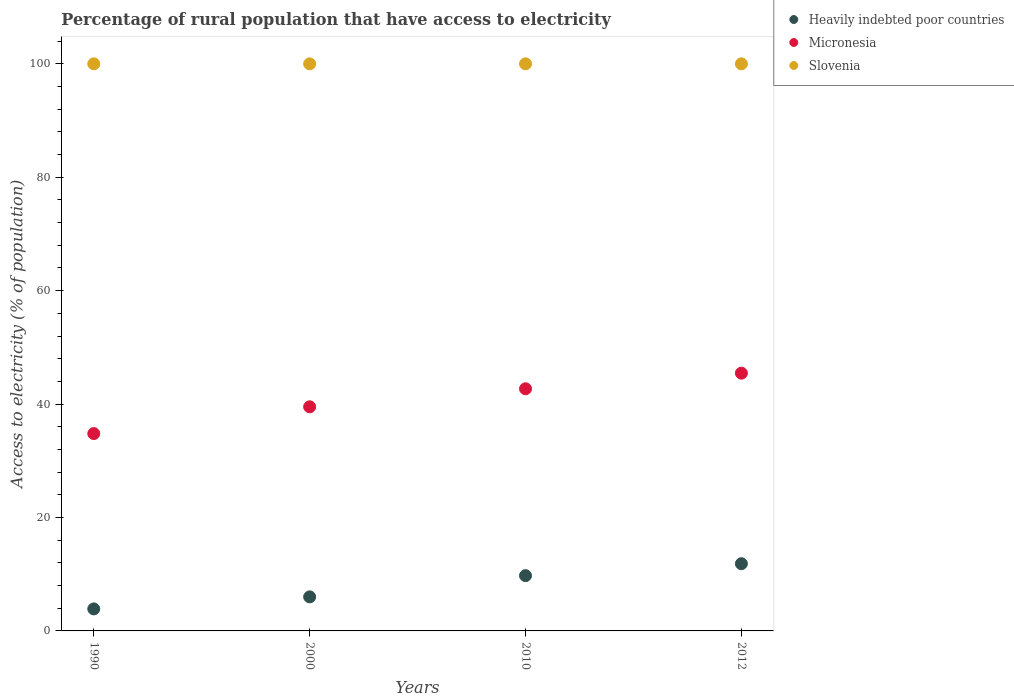How many different coloured dotlines are there?
Provide a short and direct response. 3. Is the number of dotlines equal to the number of legend labels?
Offer a very short reply. Yes. What is the percentage of rural population that have access to electricity in Heavily indebted poor countries in 2012?
Make the answer very short. 11.85. Across all years, what is the maximum percentage of rural population that have access to electricity in Heavily indebted poor countries?
Give a very brief answer. 11.85. Across all years, what is the minimum percentage of rural population that have access to electricity in Micronesia?
Make the answer very short. 34.8. In which year was the percentage of rural population that have access to electricity in Slovenia maximum?
Offer a very short reply. 1990. In which year was the percentage of rural population that have access to electricity in Slovenia minimum?
Offer a very short reply. 1990. What is the total percentage of rural population that have access to electricity in Heavily indebted poor countries in the graph?
Offer a terse response. 31.49. What is the difference between the percentage of rural population that have access to electricity in Slovenia in 1990 and that in 2000?
Give a very brief answer. 0. What is the difference between the percentage of rural population that have access to electricity in Slovenia in 1990 and the percentage of rural population that have access to electricity in Heavily indebted poor countries in 2010?
Provide a succinct answer. 90.25. In the year 2012, what is the difference between the percentage of rural population that have access to electricity in Heavily indebted poor countries and percentage of rural population that have access to electricity in Slovenia?
Ensure brevity in your answer.  -88.15. What is the ratio of the percentage of rural population that have access to electricity in Slovenia in 1990 to that in 2010?
Give a very brief answer. 1. What is the difference between the highest and the second highest percentage of rural population that have access to electricity in Heavily indebted poor countries?
Offer a very short reply. 2.11. What is the difference between the highest and the lowest percentage of rural population that have access to electricity in Heavily indebted poor countries?
Provide a succinct answer. 7.97. Is the sum of the percentage of rural population that have access to electricity in Heavily indebted poor countries in 1990 and 2000 greater than the maximum percentage of rural population that have access to electricity in Micronesia across all years?
Your response must be concise. No. Does the percentage of rural population that have access to electricity in Heavily indebted poor countries monotonically increase over the years?
Give a very brief answer. Yes. Is the percentage of rural population that have access to electricity in Heavily indebted poor countries strictly less than the percentage of rural population that have access to electricity in Slovenia over the years?
Offer a very short reply. Yes. How many dotlines are there?
Offer a terse response. 3. How many years are there in the graph?
Keep it short and to the point. 4. Where does the legend appear in the graph?
Offer a terse response. Top right. How many legend labels are there?
Give a very brief answer. 3. How are the legend labels stacked?
Offer a terse response. Vertical. What is the title of the graph?
Offer a terse response. Percentage of rural population that have access to electricity. What is the label or title of the X-axis?
Your response must be concise. Years. What is the label or title of the Y-axis?
Make the answer very short. Access to electricity (% of population). What is the Access to electricity (% of population) of Heavily indebted poor countries in 1990?
Provide a short and direct response. 3.88. What is the Access to electricity (% of population) of Micronesia in 1990?
Offer a terse response. 34.8. What is the Access to electricity (% of population) in Slovenia in 1990?
Ensure brevity in your answer.  100. What is the Access to electricity (% of population) of Heavily indebted poor countries in 2000?
Your answer should be very brief. 6. What is the Access to electricity (% of population) in Micronesia in 2000?
Make the answer very short. 39.52. What is the Access to electricity (% of population) of Slovenia in 2000?
Keep it short and to the point. 100. What is the Access to electricity (% of population) of Heavily indebted poor countries in 2010?
Give a very brief answer. 9.75. What is the Access to electricity (% of population) in Micronesia in 2010?
Give a very brief answer. 42.7. What is the Access to electricity (% of population) in Slovenia in 2010?
Your answer should be very brief. 100. What is the Access to electricity (% of population) in Heavily indebted poor countries in 2012?
Keep it short and to the point. 11.85. What is the Access to electricity (% of population) in Micronesia in 2012?
Your response must be concise. 45.45. Across all years, what is the maximum Access to electricity (% of population) of Heavily indebted poor countries?
Offer a terse response. 11.85. Across all years, what is the maximum Access to electricity (% of population) in Micronesia?
Your response must be concise. 45.45. Across all years, what is the minimum Access to electricity (% of population) of Heavily indebted poor countries?
Your answer should be very brief. 3.88. Across all years, what is the minimum Access to electricity (% of population) in Micronesia?
Make the answer very short. 34.8. What is the total Access to electricity (% of population) of Heavily indebted poor countries in the graph?
Provide a succinct answer. 31.49. What is the total Access to electricity (% of population) of Micronesia in the graph?
Your answer should be very brief. 162.47. What is the total Access to electricity (% of population) in Slovenia in the graph?
Ensure brevity in your answer.  400. What is the difference between the Access to electricity (% of population) of Heavily indebted poor countries in 1990 and that in 2000?
Your answer should be very brief. -2.12. What is the difference between the Access to electricity (% of population) in Micronesia in 1990 and that in 2000?
Make the answer very short. -4.72. What is the difference between the Access to electricity (% of population) in Heavily indebted poor countries in 1990 and that in 2010?
Provide a succinct answer. -5.86. What is the difference between the Access to electricity (% of population) in Micronesia in 1990 and that in 2010?
Make the answer very short. -7.9. What is the difference between the Access to electricity (% of population) of Heavily indebted poor countries in 1990 and that in 2012?
Your answer should be very brief. -7.97. What is the difference between the Access to electricity (% of population) in Micronesia in 1990 and that in 2012?
Your answer should be compact. -10.66. What is the difference between the Access to electricity (% of population) of Slovenia in 1990 and that in 2012?
Provide a succinct answer. 0. What is the difference between the Access to electricity (% of population) of Heavily indebted poor countries in 2000 and that in 2010?
Ensure brevity in your answer.  -3.74. What is the difference between the Access to electricity (% of population) of Micronesia in 2000 and that in 2010?
Your answer should be compact. -3.18. What is the difference between the Access to electricity (% of population) of Heavily indebted poor countries in 2000 and that in 2012?
Provide a short and direct response. -5.85. What is the difference between the Access to electricity (% of population) of Micronesia in 2000 and that in 2012?
Make the answer very short. -5.93. What is the difference between the Access to electricity (% of population) in Heavily indebted poor countries in 2010 and that in 2012?
Offer a very short reply. -2.11. What is the difference between the Access to electricity (% of population) of Micronesia in 2010 and that in 2012?
Make the answer very short. -2.75. What is the difference between the Access to electricity (% of population) in Heavily indebted poor countries in 1990 and the Access to electricity (% of population) in Micronesia in 2000?
Provide a short and direct response. -35.64. What is the difference between the Access to electricity (% of population) in Heavily indebted poor countries in 1990 and the Access to electricity (% of population) in Slovenia in 2000?
Ensure brevity in your answer.  -96.12. What is the difference between the Access to electricity (% of population) of Micronesia in 1990 and the Access to electricity (% of population) of Slovenia in 2000?
Make the answer very short. -65.2. What is the difference between the Access to electricity (% of population) of Heavily indebted poor countries in 1990 and the Access to electricity (% of population) of Micronesia in 2010?
Your answer should be very brief. -38.82. What is the difference between the Access to electricity (% of population) of Heavily indebted poor countries in 1990 and the Access to electricity (% of population) of Slovenia in 2010?
Your answer should be compact. -96.12. What is the difference between the Access to electricity (% of population) in Micronesia in 1990 and the Access to electricity (% of population) in Slovenia in 2010?
Your response must be concise. -65.2. What is the difference between the Access to electricity (% of population) in Heavily indebted poor countries in 1990 and the Access to electricity (% of population) in Micronesia in 2012?
Your answer should be compact. -41.57. What is the difference between the Access to electricity (% of population) in Heavily indebted poor countries in 1990 and the Access to electricity (% of population) in Slovenia in 2012?
Offer a terse response. -96.12. What is the difference between the Access to electricity (% of population) of Micronesia in 1990 and the Access to electricity (% of population) of Slovenia in 2012?
Your answer should be very brief. -65.2. What is the difference between the Access to electricity (% of population) of Heavily indebted poor countries in 2000 and the Access to electricity (% of population) of Micronesia in 2010?
Make the answer very short. -36.7. What is the difference between the Access to electricity (% of population) of Heavily indebted poor countries in 2000 and the Access to electricity (% of population) of Slovenia in 2010?
Make the answer very short. -94. What is the difference between the Access to electricity (% of population) of Micronesia in 2000 and the Access to electricity (% of population) of Slovenia in 2010?
Offer a terse response. -60.48. What is the difference between the Access to electricity (% of population) in Heavily indebted poor countries in 2000 and the Access to electricity (% of population) in Micronesia in 2012?
Your answer should be very brief. -39.45. What is the difference between the Access to electricity (% of population) of Heavily indebted poor countries in 2000 and the Access to electricity (% of population) of Slovenia in 2012?
Provide a short and direct response. -94. What is the difference between the Access to electricity (% of population) in Micronesia in 2000 and the Access to electricity (% of population) in Slovenia in 2012?
Give a very brief answer. -60.48. What is the difference between the Access to electricity (% of population) of Heavily indebted poor countries in 2010 and the Access to electricity (% of population) of Micronesia in 2012?
Your answer should be compact. -35.71. What is the difference between the Access to electricity (% of population) of Heavily indebted poor countries in 2010 and the Access to electricity (% of population) of Slovenia in 2012?
Your response must be concise. -90.25. What is the difference between the Access to electricity (% of population) of Micronesia in 2010 and the Access to electricity (% of population) of Slovenia in 2012?
Your answer should be compact. -57.3. What is the average Access to electricity (% of population) of Heavily indebted poor countries per year?
Offer a terse response. 7.87. What is the average Access to electricity (% of population) in Micronesia per year?
Your response must be concise. 40.62. What is the average Access to electricity (% of population) of Slovenia per year?
Make the answer very short. 100. In the year 1990, what is the difference between the Access to electricity (% of population) in Heavily indebted poor countries and Access to electricity (% of population) in Micronesia?
Your response must be concise. -30.92. In the year 1990, what is the difference between the Access to electricity (% of population) in Heavily indebted poor countries and Access to electricity (% of population) in Slovenia?
Offer a very short reply. -96.12. In the year 1990, what is the difference between the Access to electricity (% of population) in Micronesia and Access to electricity (% of population) in Slovenia?
Keep it short and to the point. -65.2. In the year 2000, what is the difference between the Access to electricity (% of population) in Heavily indebted poor countries and Access to electricity (% of population) in Micronesia?
Provide a short and direct response. -33.52. In the year 2000, what is the difference between the Access to electricity (% of population) of Heavily indebted poor countries and Access to electricity (% of population) of Slovenia?
Provide a short and direct response. -94. In the year 2000, what is the difference between the Access to electricity (% of population) in Micronesia and Access to electricity (% of population) in Slovenia?
Offer a very short reply. -60.48. In the year 2010, what is the difference between the Access to electricity (% of population) in Heavily indebted poor countries and Access to electricity (% of population) in Micronesia?
Provide a succinct answer. -32.95. In the year 2010, what is the difference between the Access to electricity (% of population) of Heavily indebted poor countries and Access to electricity (% of population) of Slovenia?
Make the answer very short. -90.25. In the year 2010, what is the difference between the Access to electricity (% of population) in Micronesia and Access to electricity (% of population) in Slovenia?
Your response must be concise. -57.3. In the year 2012, what is the difference between the Access to electricity (% of population) of Heavily indebted poor countries and Access to electricity (% of population) of Micronesia?
Keep it short and to the point. -33.6. In the year 2012, what is the difference between the Access to electricity (% of population) in Heavily indebted poor countries and Access to electricity (% of population) in Slovenia?
Your answer should be very brief. -88.15. In the year 2012, what is the difference between the Access to electricity (% of population) in Micronesia and Access to electricity (% of population) in Slovenia?
Make the answer very short. -54.55. What is the ratio of the Access to electricity (% of population) in Heavily indebted poor countries in 1990 to that in 2000?
Keep it short and to the point. 0.65. What is the ratio of the Access to electricity (% of population) in Micronesia in 1990 to that in 2000?
Keep it short and to the point. 0.88. What is the ratio of the Access to electricity (% of population) in Slovenia in 1990 to that in 2000?
Provide a short and direct response. 1. What is the ratio of the Access to electricity (% of population) of Heavily indebted poor countries in 1990 to that in 2010?
Give a very brief answer. 0.4. What is the ratio of the Access to electricity (% of population) in Micronesia in 1990 to that in 2010?
Provide a succinct answer. 0.81. What is the ratio of the Access to electricity (% of population) in Heavily indebted poor countries in 1990 to that in 2012?
Your answer should be compact. 0.33. What is the ratio of the Access to electricity (% of population) in Micronesia in 1990 to that in 2012?
Your answer should be compact. 0.77. What is the ratio of the Access to electricity (% of population) of Slovenia in 1990 to that in 2012?
Ensure brevity in your answer.  1. What is the ratio of the Access to electricity (% of population) of Heavily indebted poor countries in 2000 to that in 2010?
Your answer should be compact. 0.62. What is the ratio of the Access to electricity (% of population) in Micronesia in 2000 to that in 2010?
Your response must be concise. 0.93. What is the ratio of the Access to electricity (% of population) of Heavily indebted poor countries in 2000 to that in 2012?
Your response must be concise. 0.51. What is the ratio of the Access to electricity (% of population) in Micronesia in 2000 to that in 2012?
Keep it short and to the point. 0.87. What is the ratio of the Access to electricity (% of population) in Slovenia in 2000 to that in 2012?
Offer a terse response. 1. What is the ratio of the Access to electricity (% of population) in Heavily indebted poor countries in 2010 to that in 2012?
Make the answer very short. 0.82. What is the ratio of the Access to electricity (% of population) of Micronesia in 2010 to that in 2012?
Offer a terse response. 0.94. What is the ratio of the Access to electricity (% of population) in Slovenia in 2010 to that in 2012?
Provide a short and direct response. 1. What is the difference between the highest and the second highest Access to electricity (% of population) in Heavily indebted poor countries?
Your answer should be very brief. 2.11. What is the difference between the highest and the second highest Access to electricity (% of population) in Micronesia?
Your answer should be compact. 2.75. What is the difference between the highest and the second highest Access to electricity (% of population) in Slovenia?
Your answer should be compact. 0. What is the difference between the highest and the lowest Access to electricity (% of population) of Heavily indebted poor countries?
Offer a very short reply. 7.97. What is the difference between the highest and the lowest Access to electricity (% of population) in Micronesia?
Your answer should be compact. 10.66. What is the difference between the highest and the lowest Access to electricity (% of population) in Slovenia?
Offer a terse response. 0. 